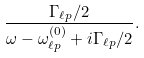Convert formula to latex. <formula><loc_0><loc_0><loc_500><loc_500>\frac { \Gamma _ { \ell p } / 2 } { \omega - \omega ^ { ( 0 ) } _ { \ell p } + i \Gamma _ { \ell p } / 2 } .</formula> 